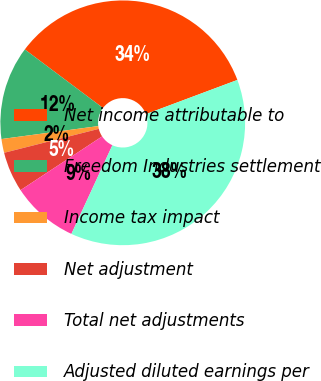Convert chart to OTSL. <chart><loc_0><loc_0><loc_500><loc_500><pie_chart><fcel>Net income attributable to<fcel>Freedom Industries settlement<fcel>Income tax impact<fcel>Net adjustment<fcel>Total net adjustments<fcel>Adjusted diluted earnings per<nl><fcel>34.07%<fcel>12.35%<fcel>1.82%<fcel>5.33%<fcel>8.84%<fcel>37.58%<nl></chart> 